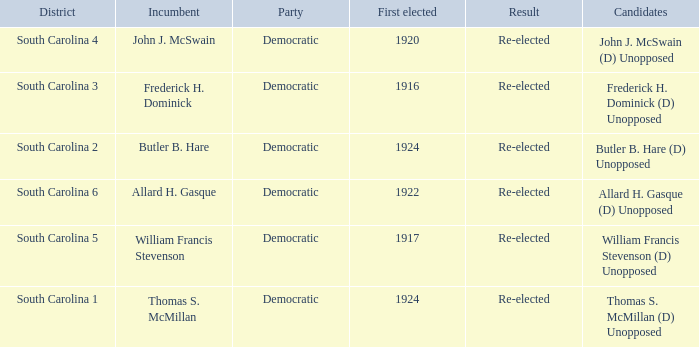What is the result for thomas s. mcmillan? Re-elected. 